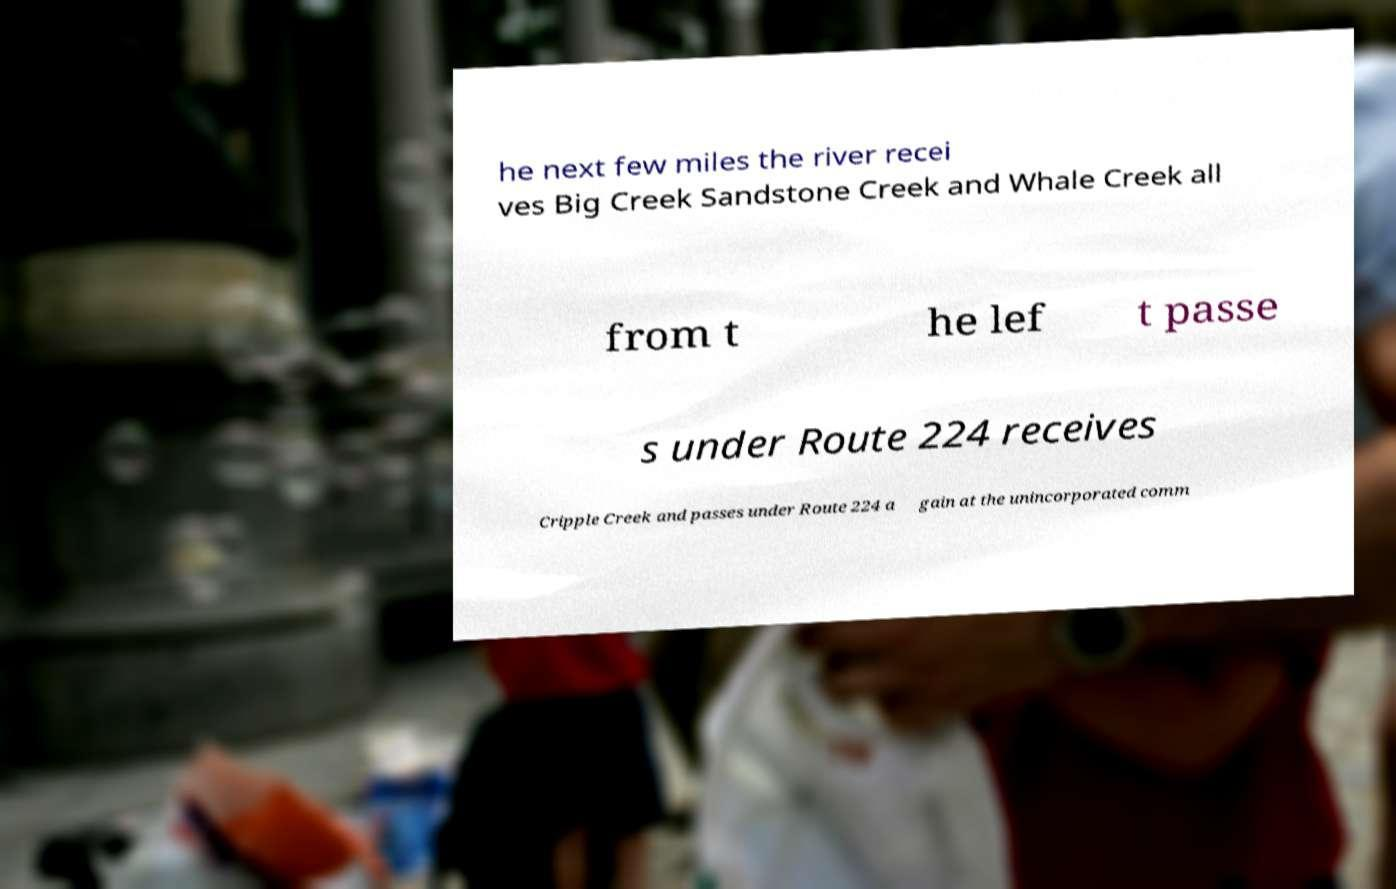Please read and relay the text visible in this image. What does it say? he next few miles the river recei ves Big Creek Sandstone Creek and Whale Creek all from t he lef t passe s under Route 224 receives Cripple Creek and passes under Route 224 a gain at the unincorporated comm 